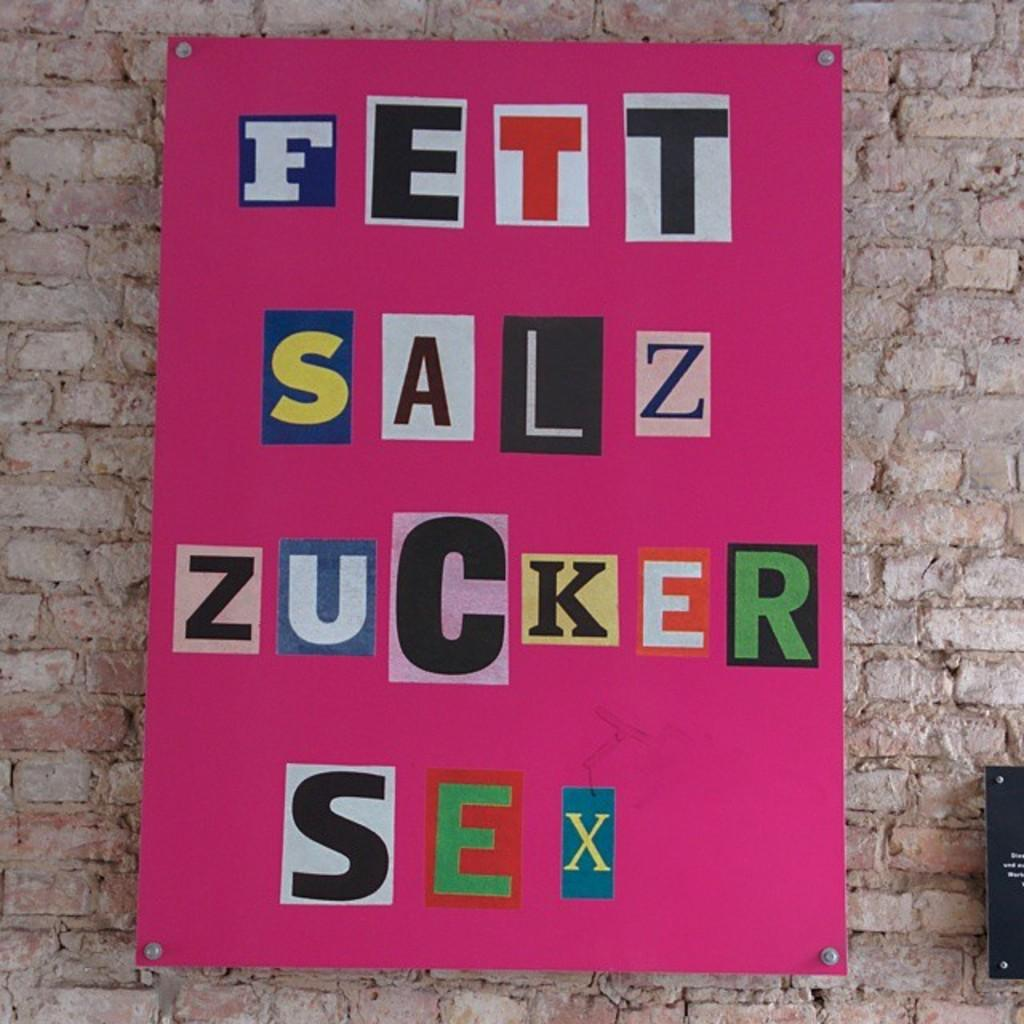Provide a one-sentence caption for the provided image. On the brick wall hanging a pink board with german words " Fett Salz Zucker Sex". 